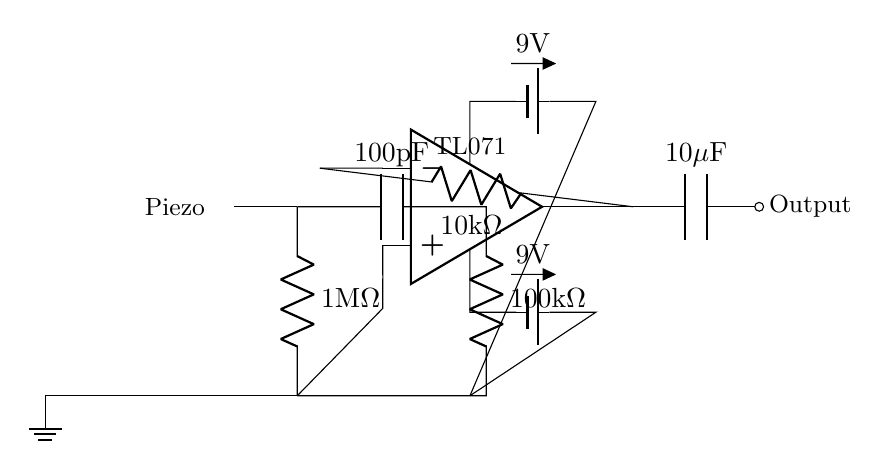What is the value of the resistor connected to the piezoelectric pickup? The resistor connected to the piezoelectric pickup is a one mega-ohm resistor. This can be observed in the circuit where it is labeled next to the 1MΩ symbol.
Answer: 1 megohm What type of operational amplifier is used in this circuit? The operational amplifier used in this circuit is labeled as TL071. This is indicated at the top of the op-amp symbol in the circuit diagram.
Answer: TL071 What is the value of the capacitor connected to the output? The capacitor connected to the output is a ten microfarad capacitor. This is marked next to the 10μF symbol in the circuit, signifying its capacitance value.
Answer: 10 microfarads How many volts are supplied to the op-amp? The voltage supplied to the op-amp is nine volts. This is indicated by the battery symbols connected to both the upper and lower terminals of the op-amp.
Answer: 9 volts Which component is responsible for converting mechanical vibrations into electrical signals? The component responsible for converting mechanical vibrations into electrical signals is the piezoelectric pickup. This is represented by the piezoelectric symbol at the left of the circuit diagram.
Answer: Piezoelectric pickup What type of circuit is this designed for? This circuit is specifically designed for low power amplification in acoustic instruments. This can be inferred from the components chosen and their configuration, which are suitable for amplifying signals from acoustic pickups.
Answer: Low power amplification 